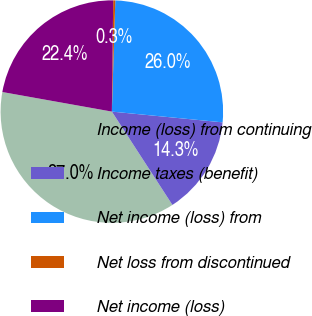<chart> <loc_0><loc_0><loc_500><loc_500><pie_chart><fcel>Income (loss) from continuing<fcel>Income taxes (benefit)<fcel>Net income (loss) from<fcel>Net loss from discontinued<fcel>Net income (loss)<nl><fcel>36.98%<fcel>14.3%<fcel>26.05%<fcel>0.3%<fcel>22.38%<nl></chart> 